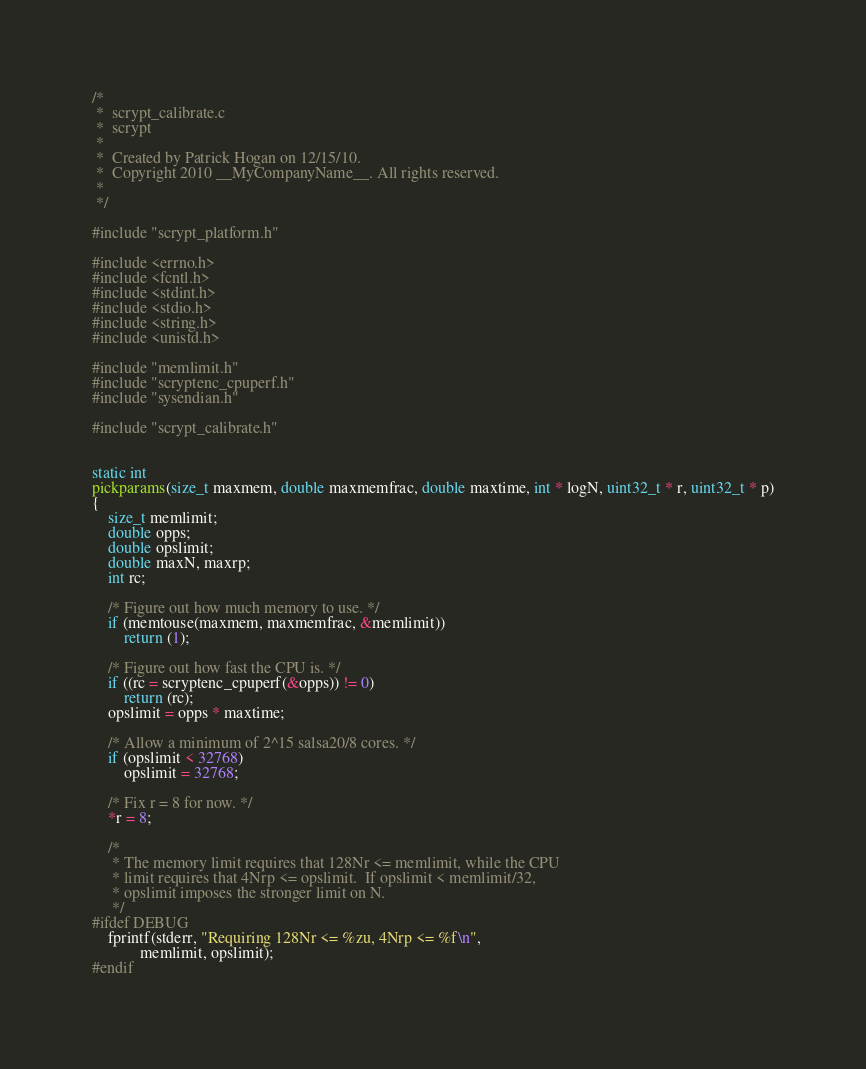Convert code to text. <code><loc_0><loc_0><loc_500><loc_500><_C_>/*
 *  scrypt_calibrate.c
 *  scrypt
 *
 *  Created by Patrick Hogan on 12/15/10.
 *  Copyright 2010 __MyCompanyName__. All rights reserved.
 *
 */

#include "scrypt_platform.h"

#include <errno.h>
#include <fcntl.h>
#include <stdint.h>
#include <stdio.h>
#include <string.h>
#include <unistd.h>

#include "memlimit.h"
#include "scryptenc_cpuperf.h"
#include "sysendian.h"

#include "scrypt_calibrate.h"


static int
pickparams(size_t maxmem, double maxmemfrac, double maxtime, int * logN, uint32_t * r, uint32_t * p)
{
	size_t memlimit;
	double opps;
	double opslimit;
	double maxN, maxrp;
	int rc;

	/* Figure out how much memory to use. */
	if (memtouse(maxmem, maxmemfrac, &memlimit))
		return (1);

	/* Figure out how fast the CPU is. */
	if ((rc = scryptenc_cpuperf(&opps)) != 0)
		return (rc);
	opslimit = opps * maxtime;

	/* Allow a minimum of 2^15 salsa20/8 cores. */
	if (opslimit < 32768)
		opslimit = 32768;

	/* Fix r = 8 for now. */
	*r = 8;

	/*
	 * The memory limit requires that 128Nr <= memlimit, while the CPU
	 * limit requires that 4Nrp <= opslimit.  If opslimit < memlimit/32,
	 * opslimit imposes the stronger limit on N.
	 */
#ifdef DEBUG
	fprintf(stderr, "Requiring 128Nr <= %zu, 4Nrp <= %f\n",
			memlimit, opslimit);
#endif</code> 